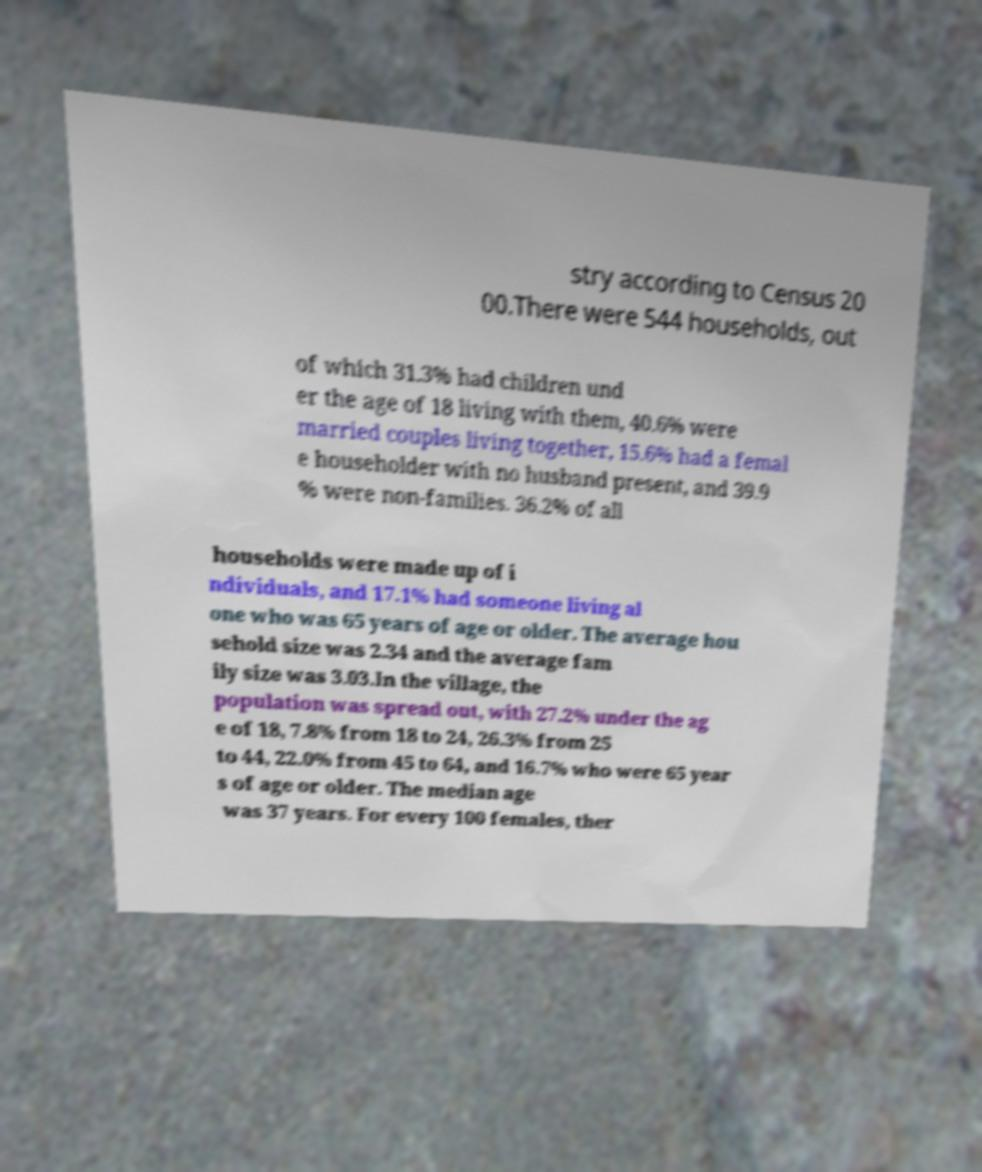There's text embedded in this image that I need extracted. Can you transcribe it verbatim? stry according to Census 20 00.There were 544 households, out of which 31.3% had children und er the age of 18 living with them, 40.6% were married couples living together, 15.6% had a femal e householder with no husband present, and 39.9 % were non-families. 36.2% of all households were made up of i ndividuals, and 17.1% had someone living al one who was 65 years of age or older. The average hou sehold size was 2.34 and the average fam ily size was 3.03.In the village, the population was spread out, with 27.2% under the ag e of 18, 7.8% from 18 to 24, 26.3% from 25 to 44, 22.0% from 45 to 64, and 16.7% who were 65 year s of age or older. The median age was 37 years. For every 100 females, ther 